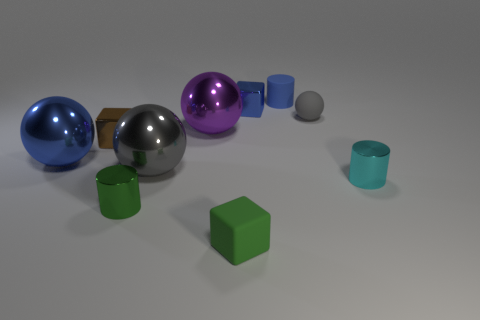Subtract 2 balls. How many balls are left? 2 Subtract all blue metallic spheres. How many spheres are left? 3 Subtract all brown spheres. Subtract all purple blocks. How many spheres are left? 4 Subtract all cylinders. How many objects are left? 7 Subtract all blue metallic spheres. Subtract all gray matte spheres. How many objects are left? 8 Add 2 gray spheres. How many gray spheres are left? 4 Add 5 large brown shiny blocks. How many large brown shiny blocks exist? 5 Subtract 1 purple spheres. How many objects are left? 9 